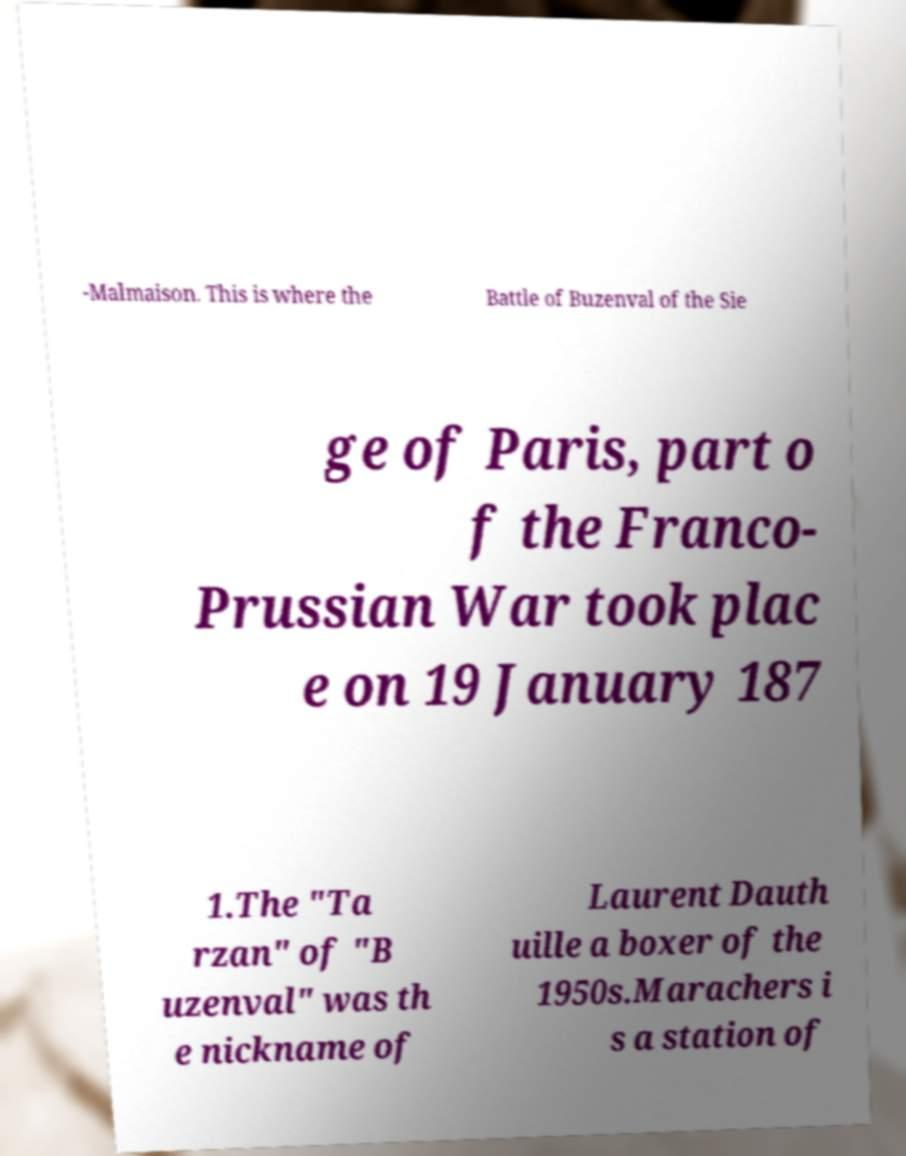Could you extract and type out the text from this image? -Malmaison. This is where the Battle of Buzenval of the Sie ge of Paris, part o f the Franco- Prussian War took plac e on 19 January 187 1.The "Ta rzan" of "B uzenval" was th e nickname of Laurent Dauth uille a boxer of the 1950s.Marachers i s a station of 